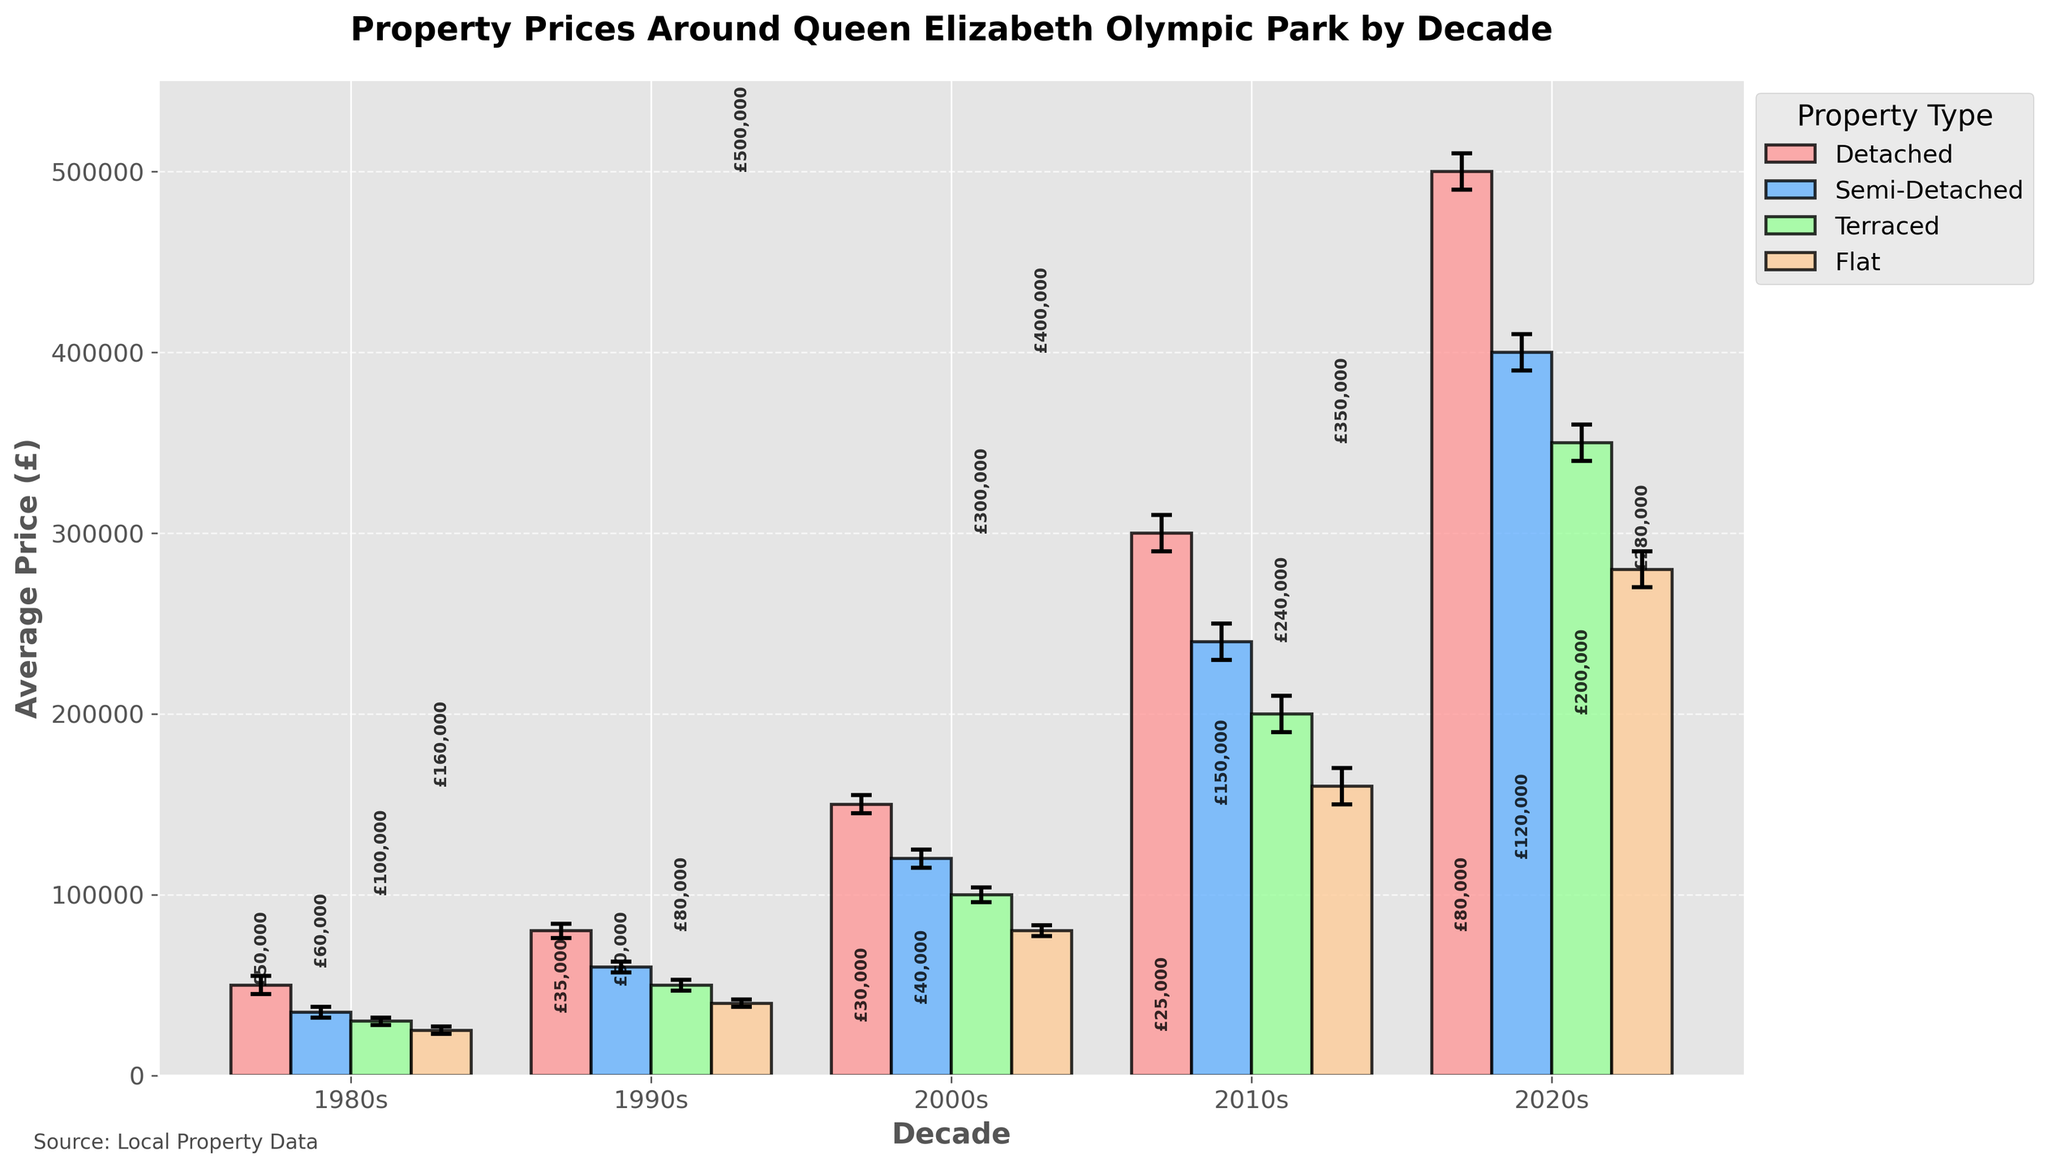How many decades are presented in the figure? By examining the x-axis of the figure, we see labels representing different decades: 1980s, 1990s, 2000s, 2010s, and 2020s.
Answer: 5 Which property type had the highest average price in the 2020s? By comparing the heights of the bars for the 2020s, the tallest bar represents Detached properties.
Answer: Detached What is the average price difference between the Detached and Flat property types in the 1990s? From the figure, the average price of Detached properties in the 1990s is £80,000, and for Flats, it is £40,000. The difference is £80,000 - £40,000.
Answer: £40,000 Which decade saw the most significant increase in average property prices for Semi-Detached properties? By observing the bars corresponding to Semi-Detached properties across decades, the jump from the 2010s (£240,000) to the 2020s (£400,000) is the most significant.
Answer: 2020s What are the lower and upper confidence intervals for Terraced properties in the 2000s? By looking at the error bars for Terraced properties in the 2000s, the lower confidence interval is £96,000, and the upper confidence interval is £104,000.
Answer: £96,000 and £104,000 In which decade do Flat properties show the highest variation in prices (based on confidence intervals)? Variation in prices is seen by the length of the error bars. Flats in the 2020s have the longest error bars, indicating the highest variation.
Answer: 2020s By how much did the average price of Detached properties change from the 1980s to the 2010s? The average price of Detached properties in the 1980s was £50,000, and in the 2010s was £300,000. The change is £300,000 - £50,000.
Answer: £250,000 Compare the average prices of Semi-Detached properties in the 1990s and 2010s. Which decade has a higher average price? The average price for Semi-Detached properties in the 1990s is £60,000, and in the 2010s is £240,000. The 2010s have a higher average price.
Answer: 2010s Which property type showed a consistent increase in average prices each decade? By observing the trends in the bars across all decades, Detached properties show a consistent increase every decade.
Answer: Detached 